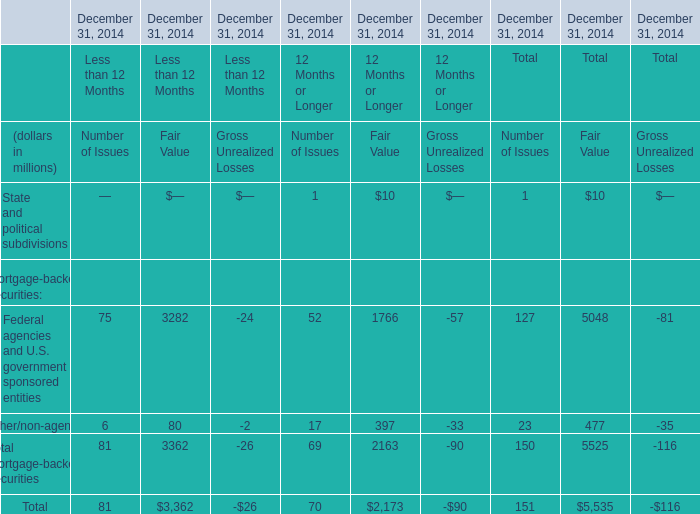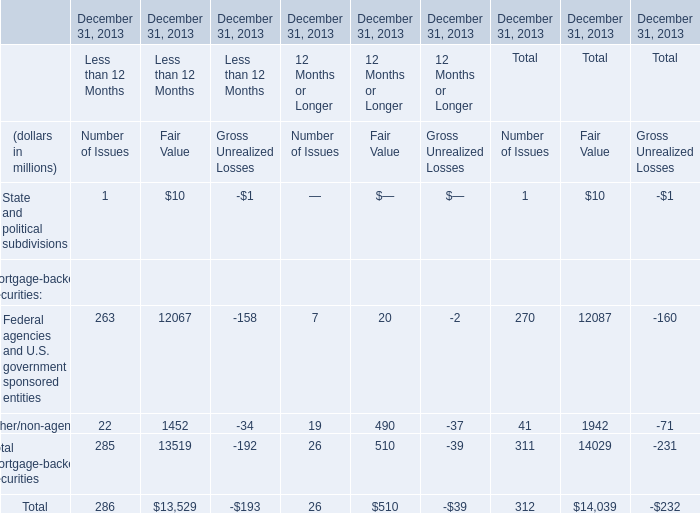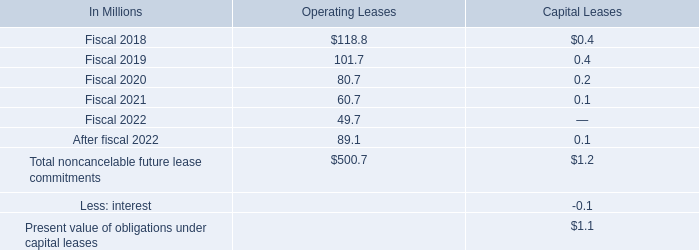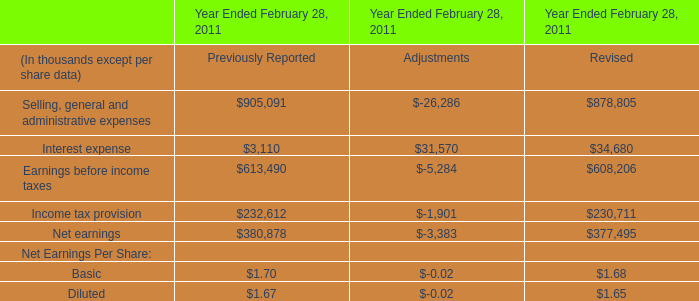what will be the percentage decrease in operating leases from 2017 to 2018? 
Computations: ((118.8 - 188.1) / 188.1)
Answer: -0.36842. 